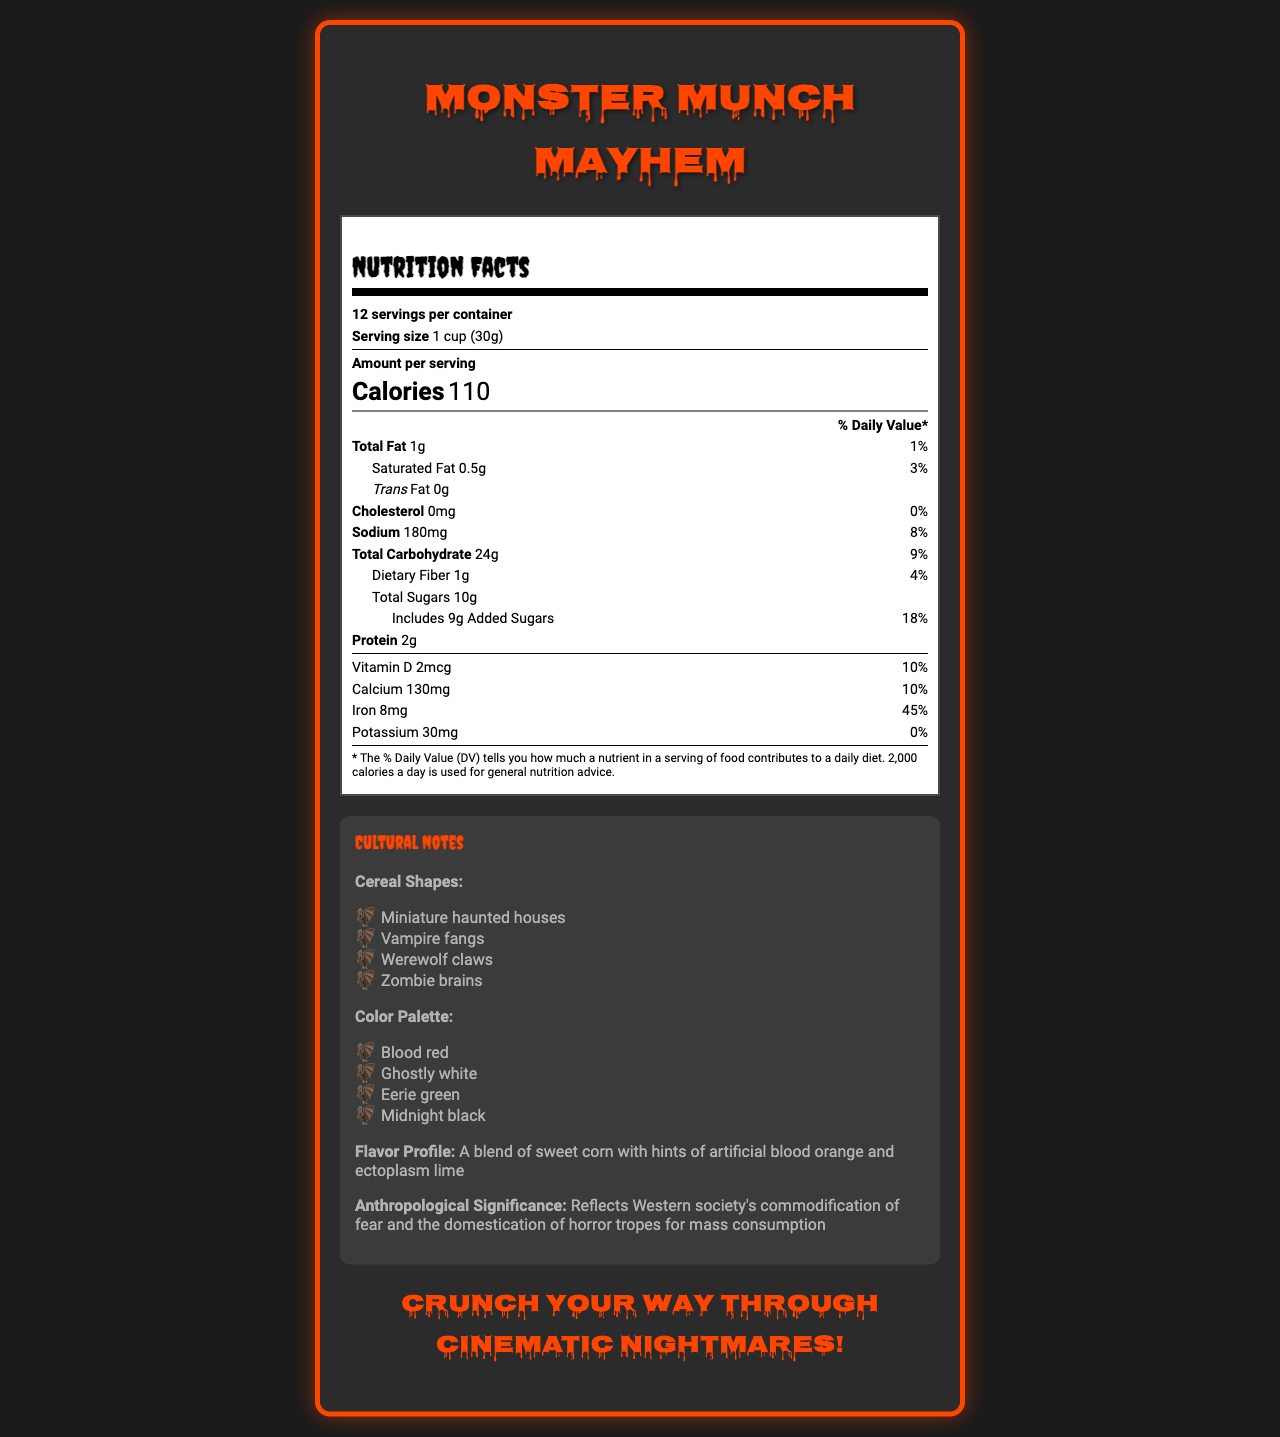what is the serving size of Monster Munch Mayhem? The serving size is listed as 1 cup (30g) in the nutrition facts section.
Answer: 1 cup (30g) how many grams of protein are in one serving of Monster Munch Mayhem? The protein content for one serving is specified as 2g in the nutrition facts section.
Answer: 2g how many total servings are in one container? The document states that there are 12 servings per container.
Answer: 12 what is the marketing tagline for Monster Munch Mayhem? The marketing tagline is featured at the bottom of the document.
Answer: Crunch your way through cinematic nightmares! list three colors used in the cereal's color palette The color palette mentioned in the cultural notes includes Blood red, Ghostly white, Eerie green, and Midnight black.
Answer: Blood red, Ghostly white, Eerie green which nutrient has the highest % Daily Value in Monster Munch Mayhem? A. Calcium B. Iron C. Vitamin D D. Sodium Iron has a % Daily Value of 45%, which is the highest among the listed nutrients.
Answer: B. Iron what is the total fat content per serving? A. 0g B. 0.5g C. 1g D. 2g The total fat content per serving of Monster Munch Mayhem is 1g.
Answer: C. 1g is Monster Munch Mayhem suitable for someone watching their cholesterol intake? The cereal contains 0mg of cholesterol, making it suitable for individuals watching their cholesterol intake.
Answer: Yes describe the main idea represented in the document The document encompasses the nutrition facts, marketing elements, and cultural significance of the Monster Munch Mayhem cereal, which ties popular horror elements with everyday consumer products.
Answer: Monster Munch Mayhem is a novelty cereal with a horror movie theme, featuring unique shapes and colors inspired by horror tropes. The document provides detailed nutritional information, highlighting its blend of sweet corn with artificial flavors and noting the anthropological significance of commodifying cultural fears. how much dietary fiber does one serving provide? The amount of dietary fiber per serving is listed as 1g.
Answer: 1g does the cereal contain any added sugars? The document mentions that each serving includes 9g of added sugars.
Answer: Yes explain the flavor profile of Monster Munch Mayhem The flavor profile combines sweet corn with artificial blood orange and ectoplasm lime, as stated in the document.
Answer: The flavor profile is described as a blend of sweet corn with hints of artificial blood orange and ectoplasm lime. how many grams of sodium are in one serving? The sodium content is 180mg per serving.
Answer: 180mg what is the significance of the "Ectoplasm lime" flavor in the cereal? Ectoplasm lime ties into horror movie elements and flavors inspired by supernatural themes, reinforcing the horror movie trope.
Answer: Reflects the use of supernatural elements in horror pop culture are the ingredients predominantly artificial or natural? The ingredients list includes both natural (e.g., whole grain corn) and artificial components (e.g., artificial flavors).
Answer: Both how many grams of total carbohydrate are in one serving? The total carbohydrate content is 24g per serving as per the nutrition facts section.
Answer: 24g how does Monster Munch Mayhem reflect Western society's relationship with horror? The document notes that the cereal reflects the commodification of cultural fears and the domestication of horror tropes, making them accessible and marketable to a wider audience.
Answer: It commodifies fear and domesticates horror tropes for mass consumption is there an allergen warning for Monster Munch Mayhem? The cereal contains corn and may contain traces of wheat and soy, as indicated in the allergen info.
Answer: Yes what is the range of daily values (%) for the nutrients listed? The % Daily Value for nutrients ranges from 0% (Potassium) to 45% (Iron), as indicated in the nutrition facts section.
Answer: 0% to 45% how many calories does one serving provide? Each serving provides 110 calories, as stated in the nutrition facts.
Answer: 110 where does the document mention that the trans fat content is 0g? The trans fat content is listed under the total fat section of the nutrition facts.
Answer: Under the total fat section what is the anthropological significance of this cereal? The anthropological significance is stated in the cultural notes section.
Answer: Reflects Western society's commodification of fear and the domestication of horror tropes for mass consumption 